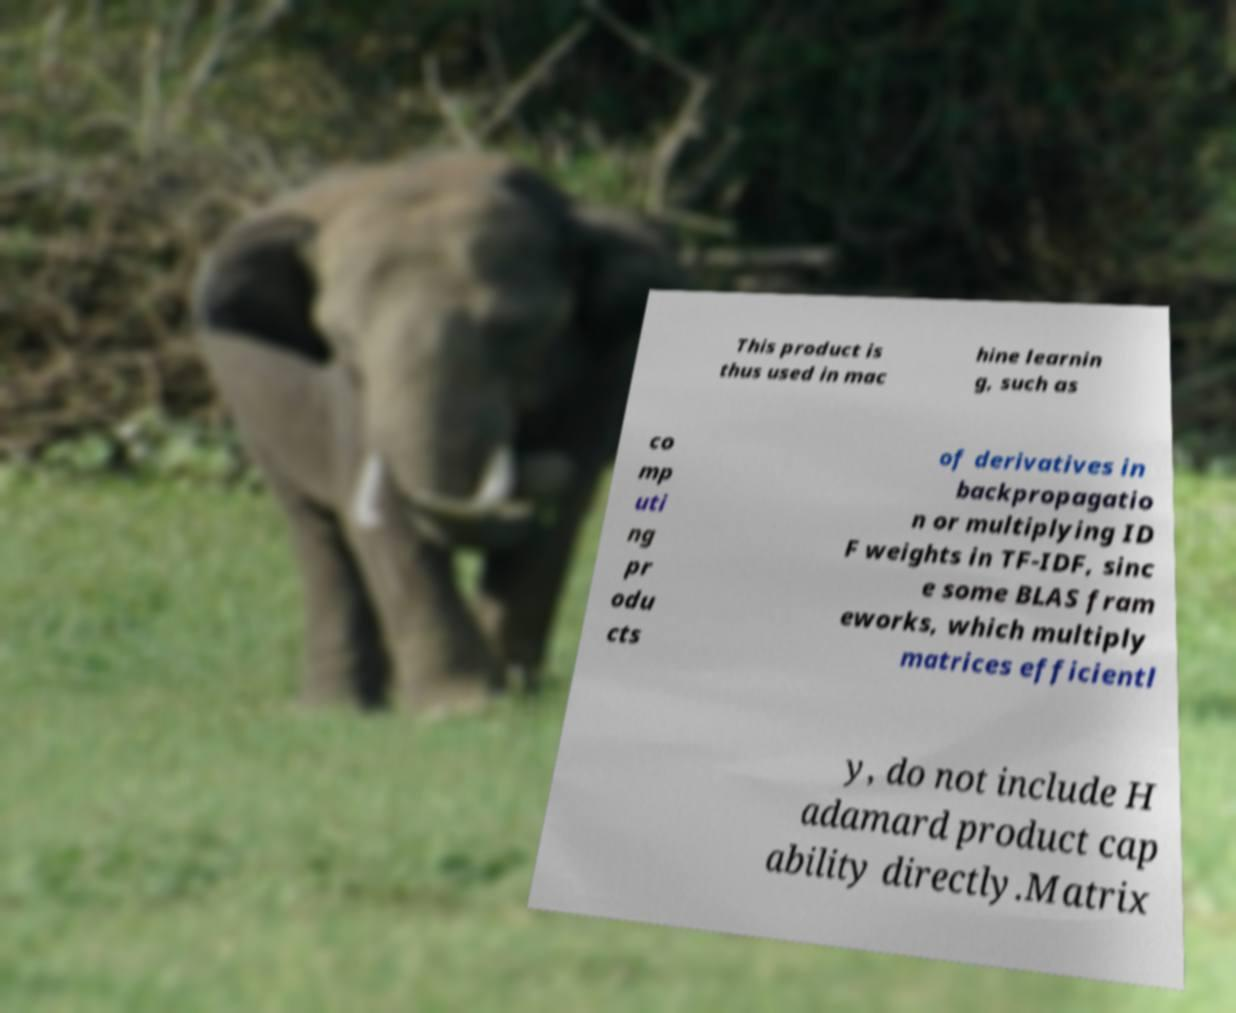Could you extract and type out the text from this image? This product is thus used in mac hine learnin g, such as co mp uti ng pr odu cts of derivatives in backpropagatio n or multiplying ID F weights in TF-IDF, sinc e some BLAS fram eworks, which multiply matrices efficientl y, do not include H adamard product cap ability directly.Matrix 